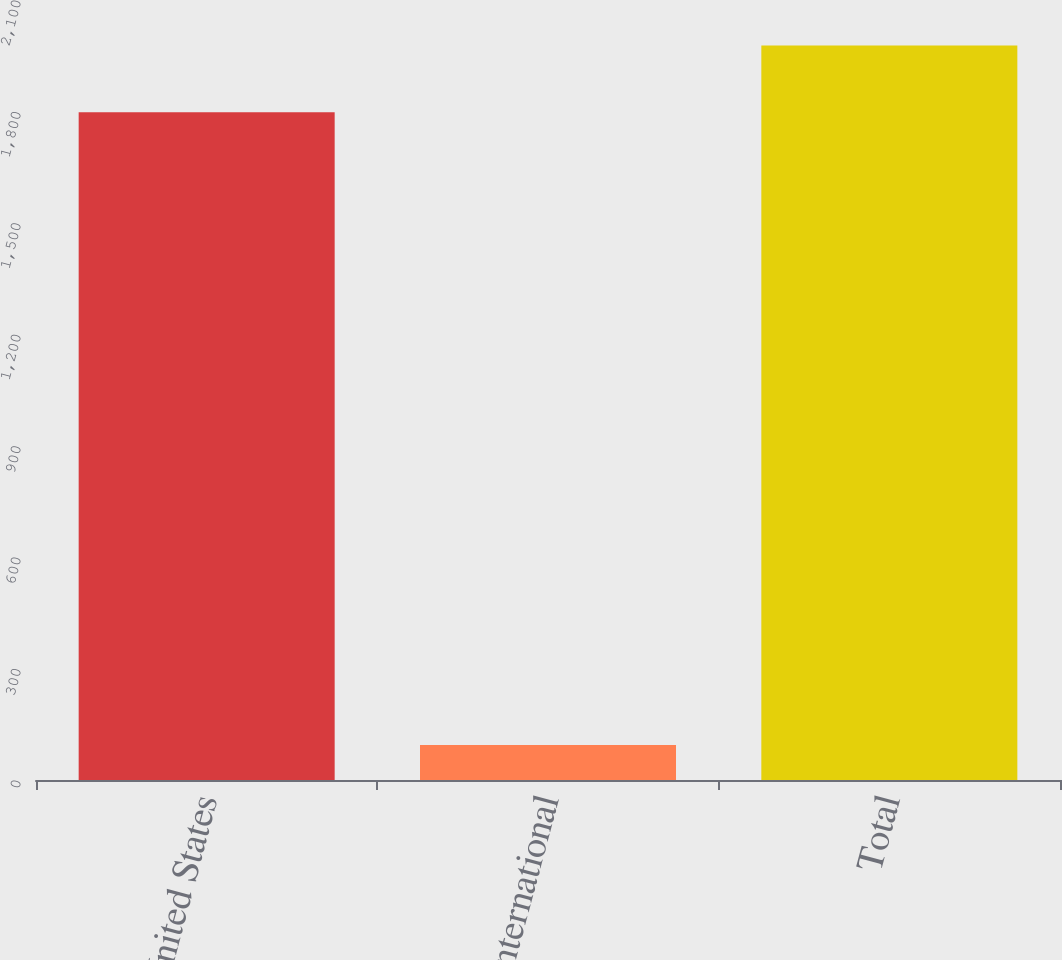<chart> <loc_0><loc_0><loc_500><loc_500><bar_chart><fcel>United States<fcel>International<fcel>Total<nl><fcel>1798<fcel>94<fcel>1977.8<nl></chart> 